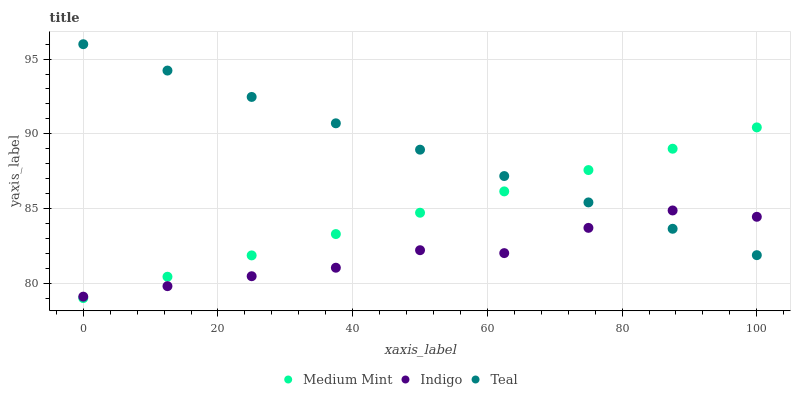Does Indigo have the minimum area under the curve?
Answer yes or no. Yes. Does Teal have the maximum area under the curve?
Answer yes or no. Yes. Does Teal have the minimum area under the curve?
Answer yes or no. No. Does Indigo have the maximum area under the curve?
Answer yes or no. No. Is Medium Mint the smoothest?
Answer yes or no. Yes. Is Indigo the roughest?
Answer yes or no. Yes. Is Teal the smoothest?
Answer yes or no. No. Is Teal the roughest?
Answer yes or no. No. Does Medium Mint have the lowest value?
Answer yes or no. Yes. Does Indigo have the lowest value?
Answer yes or no. No. Does Teal have the highest value?
Answer yes or no. Yes. Does Indigo have the highest value?
Answer yes or no. No. Does Medium Mint intersect Indigo?
Answer yes or no. Yes. Is Medium Mint less than Indigo?
Answer yes or no. No. Is Medium Mint greater than Indigo?
Answer yes or no. No. 